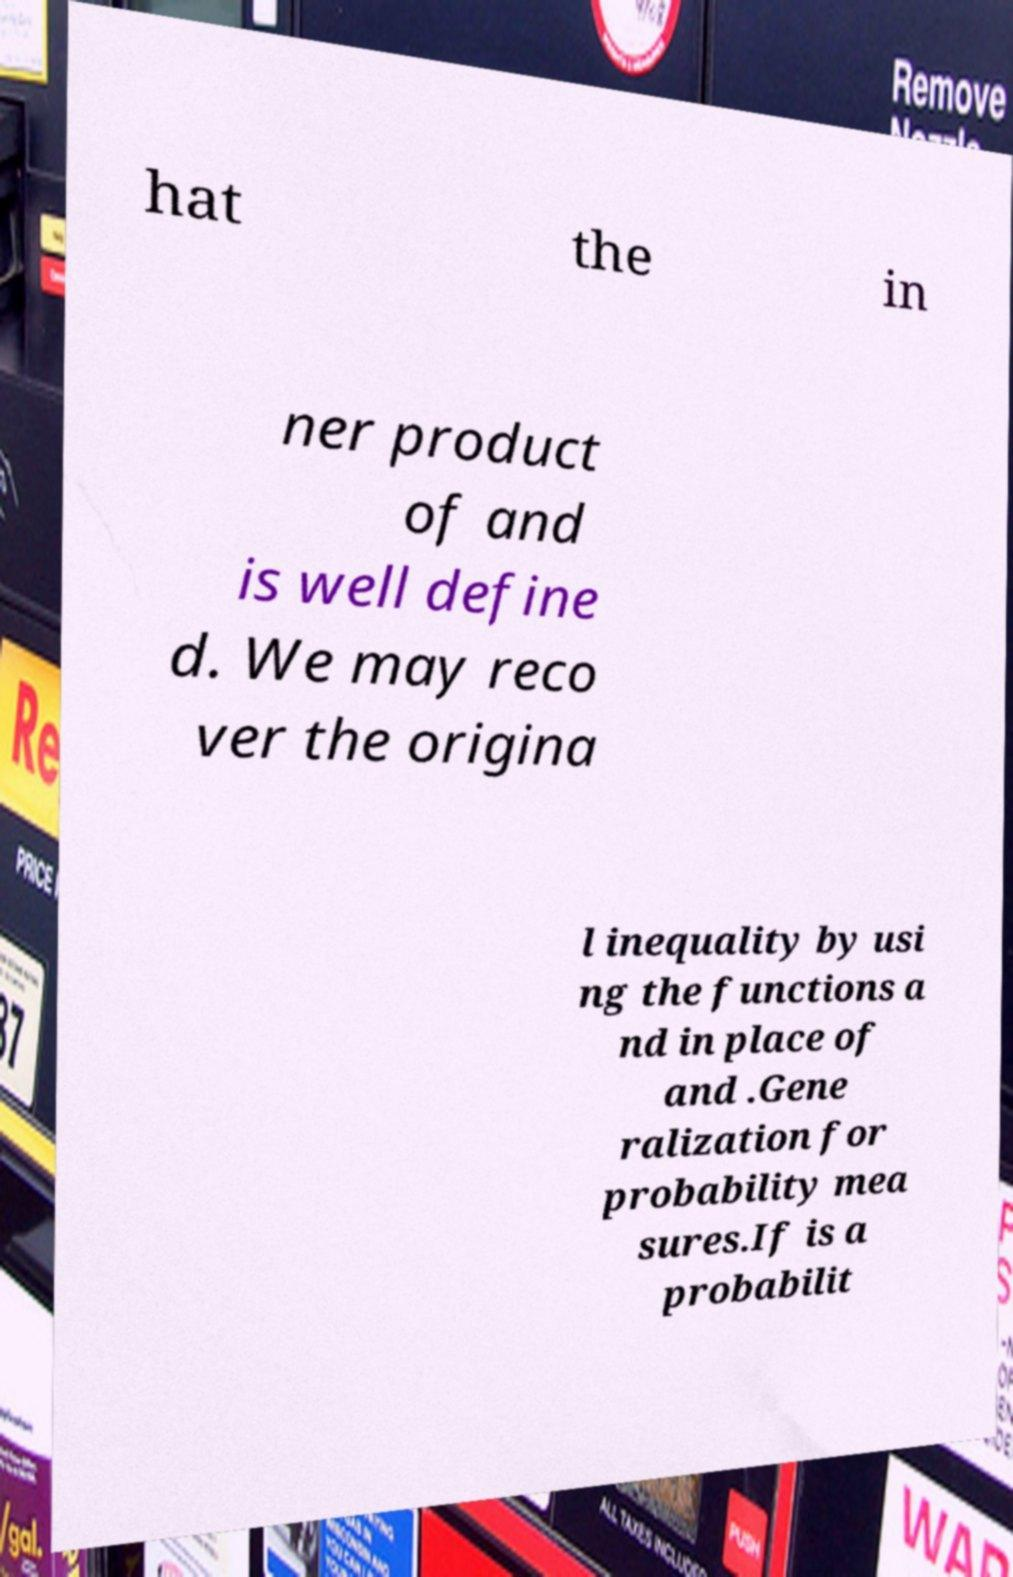What messages or text are displayed in this image? I need them in a readable, typed format. hat the in ner product of and is well define d. We may reco ver the origina l inequality by usi ng the functions a nd in place of and .Gene ralization for probability mea sures.If is a probabilit 